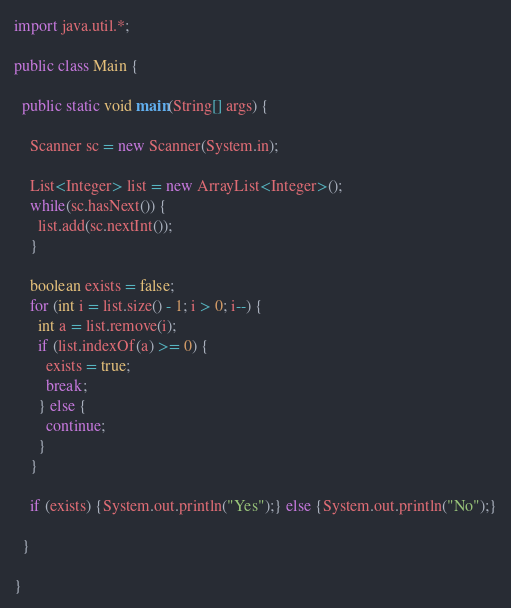<code> <loc_0><loc_0><loc_500><loc_500><_Java_>import java.util.*;

public class Main {
 
  public static void main(String[] args) {
    
    Scanner sc = new Scanner(System.in);
    
    List<Integer> list = new ArrayList<Integer>();
    while(sc.hasNext()) {
      list.add(sc.nextInt());
    }
    
    boolean exists = false;
    for (int i = list.size() - 1; i > 0; i--) {
      int a = list.remove(i);
      if (list.indexOf(a) >= 0) {
        exists = true;
        break;
      } else {
        continue;
      }
    }
    
    if (exists) {System.out.println("Yes");} else {System.out.println("No");}
    
  }
  
}</code> 